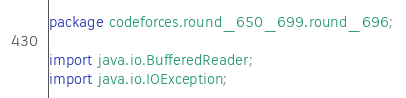Convert code to text. <code><loc_0><loc_0><loc_500><loc_500><_Java_>package codeforces.round_650_699.round_696;

import java.io.BufferedReader;
import java.io.IOException;</code> 